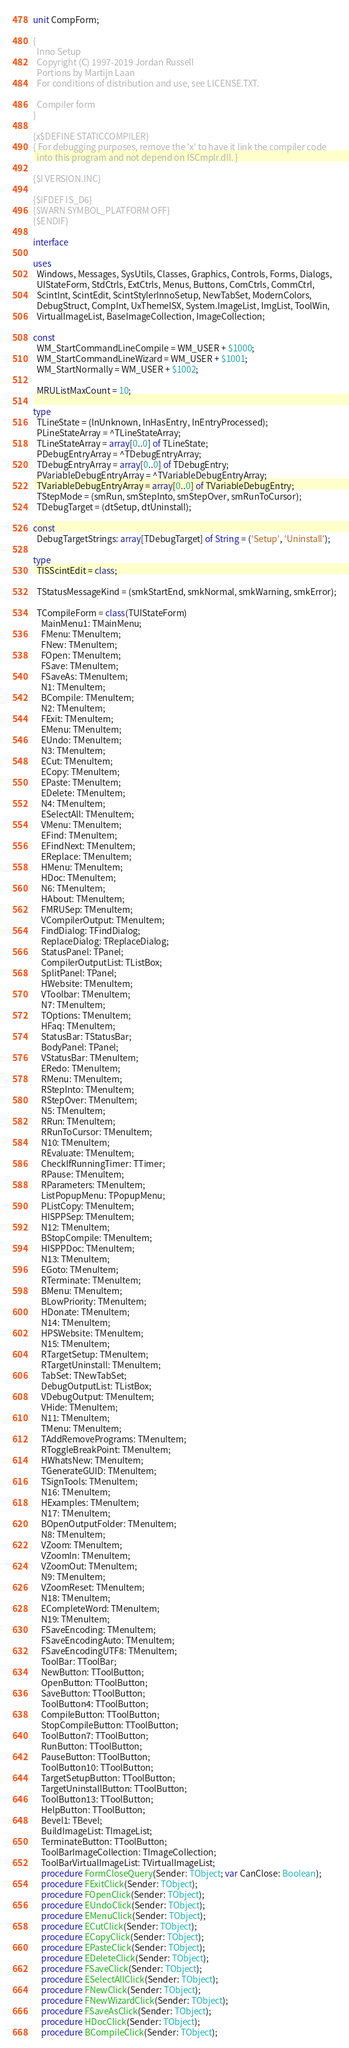Convert code to text. <code><loc_0><loc_0><loc_500><loc_500><_Pascal_>unit CompForm;

{
  Inno Setup
  Copyright (C) 1997-2019 Jordan Russell
  Portions by Martijn Laan
  For conditions of distribution and use, see LICENSE.TXT.

  Compiler form
}

{x$DEFINE STATICCOMPILER}
{ For debugging purposes, remove the 'x' to have it link the compiler code
  into this program and not depend on ISCmplr.dll. }

{$I VERSION.INC}

{$IFDEF IS_D6}
{$WARN SYMBOL_PLATFORM OFF}
{$ENDIF}

interface

uses
  Windows, Messages, SysUtils, Classes, Graphics, Controls, Forms, Dialogs,
  UIStateForm, StdCtrls, ExtCtrls, Menus, Buttons, ComCtrls, CommCtrl,
  ScintInt, ScintEdit, ScintStylerInnoSetup, NewTabSet, ModernColors,
  DebugStruct, CompInt, UxThemeISX, System.ImageList, ImgList, ToolWin,
  VirtualImageList, BaseImageCollection, ImageCollection;

const
  WM_StartCommandLineCompile = WM_USER + $1000;
  WM_StartCommandLineWizard = WM_USER + $1001;
  WM_StartNormally = WM_USER + $1002;

  MRUListMaxCount = 10;

type
  TLineState = (lnUnknown, lnHasEntry, lnEntryProcessed);
  PLineStateArray = ^TLineStateArray;
  TLineStateArray = array[0..0] of TLineState;
  PDebugEntryArray = ^TDebugEntryArray;
  TDebugEntryArray = array[0..0] of TDebugEntry;
  PVariableDebugEntryArray = ^TVariableDebugEntryArray;
  TVariableDebugEntryArray = array[0..0] of TVariableDebugEntry;
  TStepMode = (smRun, smStepInto, smStepOver, smRunToCursor);
  TDebugTarget = (dtSetup, dtUninstall);

const
  DebugTargetStrings: array[TDebugTarget] of String = ('Setup', 'Uninstall');

type
  TISScintEdit = class;

  TStatusMessageKind = (smkStartEnd, smkNormal, smkWarning, smkError);

  TCompileForm = class(TUIStateForm)
    MainMenu1: TMainMenu;
    FMenu: TMenuItem;
    FNew: TMenuItem;
    FOpen: TMenuItem;
    FSave: TMenuItem;
    FSaveAs: TMenuItem;
    N1: TMenuItem;
    BCompile: TMenuItem;
    N2: TMenuItem;
    FExit: TMenuItem;
    EMenu: TMenuItem;
    EUndo: TMenuItem;
    N3: TMenuItem;
    ECut: TMenuItem;
    ECopy: TMenuItem;
    EPaste: TMenuItem;
    EDelete: TMenuItem;
    N4: TMenuItem;
    ESelectAll: TMenuItem;
    VMenu: TMenuItem;
    EFind: TMenuItem;
    EFindNext: TMenuItem;
    EReplace: TMenuItem;
    HMenu: TMenuItem;
    HDoc: TMenuItem;
    N6: TMenuItem;
    HAbout: TMenuItem;
    FMRUSep: TMenuItem;
    VCompilerOutput: TMenuItem;
    FindDialog: TFindDialog;
    ReplaceDialog: TReplaceDialog;
    StatusPanel: TPanel;
    CompilerOutputList: TListBox;
    SplitPanel: TPanel;
    HWebsite: TMenuItem;
    VToolbar: TMenuItem;
    N7: TMenuItem;
    TOptions: TMenuItem;
    HFaq: TMenuItem;
    StatusBar: TStatusBar;
    BodyPanel: TPanel;
    VStatusBar: TMenuItem;
    ERedo: TMenuItem;
    RMenu: TMenuItem;
    RStepInto: TMenuItem;
    RStepOver: TMenuItem;
    N5: TMenuItem;
    RRun: TMenuItem;
    RRunToCursor: TMenuItem;
    N10: TMenuItem;
    REvaluate: TMenuItem;
    CheckIfRunningTimer: TTimer;
    RPause: TMenuItem;
    RParameters: TMenuItem;
    ListPopupMenu: TPopupMenu;
    PListCopy: TMenuItem;
    HISPPSep: TMenuItem;
    N12: TMenuItem;
    BStopCompile: TMenuItem;
    HISPPDoc: TMenuItem;
    N13: TMenuItem;
    EGoto: TMenuItem;
    RTerminate: TMenuItem;
    BMenu: TMenuItem;
    BLowPriority: TMenuItem;
    HDonate: TMenuItem;
    N14: TMenuItem;
    HPSWebsite: TMenuItem;
    N15: TMenuItem;
    RTargetSetup: TMenuItem;
    RTargetUninstall: TMenuItem;
    TabSet: TNewTabSet;
    DebugOutputList: TListBox;
    VDebugOutput: TMenuItem;
    VHide: TMenuItem;
    N11: TMenuItem;
    TMenu: TMenuItem;
    TAddRemovePrograms: TMenuItem;
    RToggleBreakPoint: TMenuItem;
    HWhatsNew: TMenuItem;
    TGenerateGUID: TMenuItem;
    TSignTools: TMenuItem;
    N16: TMenuItem;
    HExamples: TMenuItem;
    N17: TMenuItem;
    BOpenOutputFolder: TMenuItem;
    N8: TMenuItem;
    VZoom: TMenuItem;
    VZoomIn: TMenuItem;
    VZoomOut: TMenuItem;
    N9: TMenuItem;
    VZoomReset: TMenuItem;
    N18: TMenuItem;
    ECompleteWord: TMenuItem;
    N19: TMenuItem;
    FSaveEncoding: TMenuItem;
    FSaveEncodingAuto: TMenuItem;
    FSaveEncodingUTF8: TMenuItem;
    ToolBar: TToolBar;
    NewButton: TToolButton;
    OpenButton: TToolButton;
    SaveButton: TToolButton;
    ToolButton4: TToolButton;
    CompileButton: TToolButton;
    StopCompileButton: TToolButton;
    ToolButton7: TToolButton;
    RunButton: TToolButton;
    PauseButton: TToolButton;
    ToolButton10: TToolButton;
    TargetSetupButton: TToolButton;
    TargetUninstallButton: TToolButton;
    ToolButton13: TToolButton;
    HelpButton: TToolButton;
    Bevel1: TBevel;
    BuildImageList: TImageList;
    TerminateButton: TToolButton;
    ToolBarImageCollection: TImageCollection;
    ToolBarVirtualImageList: TVirtualImageList;
    procedure FormCloseQuery(Sender: TObject; var CanClose: Boolean);
    procedure FExitClick(Sender: TObject);
    procedure FOpenClick(Sender: TObject);
    procedure EUndoClick(Sender: TObject);
    procedure EMenuClick(Sender: TObject);
    procedure ECutClick(Sender: TObject);
    procedure ECopyClick(Sender: TObject);
    procedure EPasteClick(Sender: TObject);
    procedure EDeleteClick(Sender: TObject);
    procedure FSaveClick(Sender: TObject);
    procedure ESelectAllClick(Sender: TObject);
    procedure FNewClick(Sender: TObject);
    procedure FNewWizardClick(Sender: TObject);
    procedure FSaveAsClick(Sender: TObject);
    procedure HDocClick(Sender: TObject);
    procedure BCompileClick(Sender: TObject);</code> 